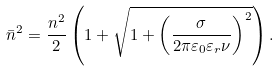Convert formula to latex. <formula><loc_0><loc_0><loc_500><loc_500>\bar { n } ^ { 2 } = \frac { n ^ { 2 } } { 2 } \left ( 1 + \sqrt { 1 + \left ( \frac { \sigma } { 2 \pi \varepsilon _ { 0 } \varepsilon _ { r } \nu } \right ) ^ { 2 } } \right ) .</formula> 